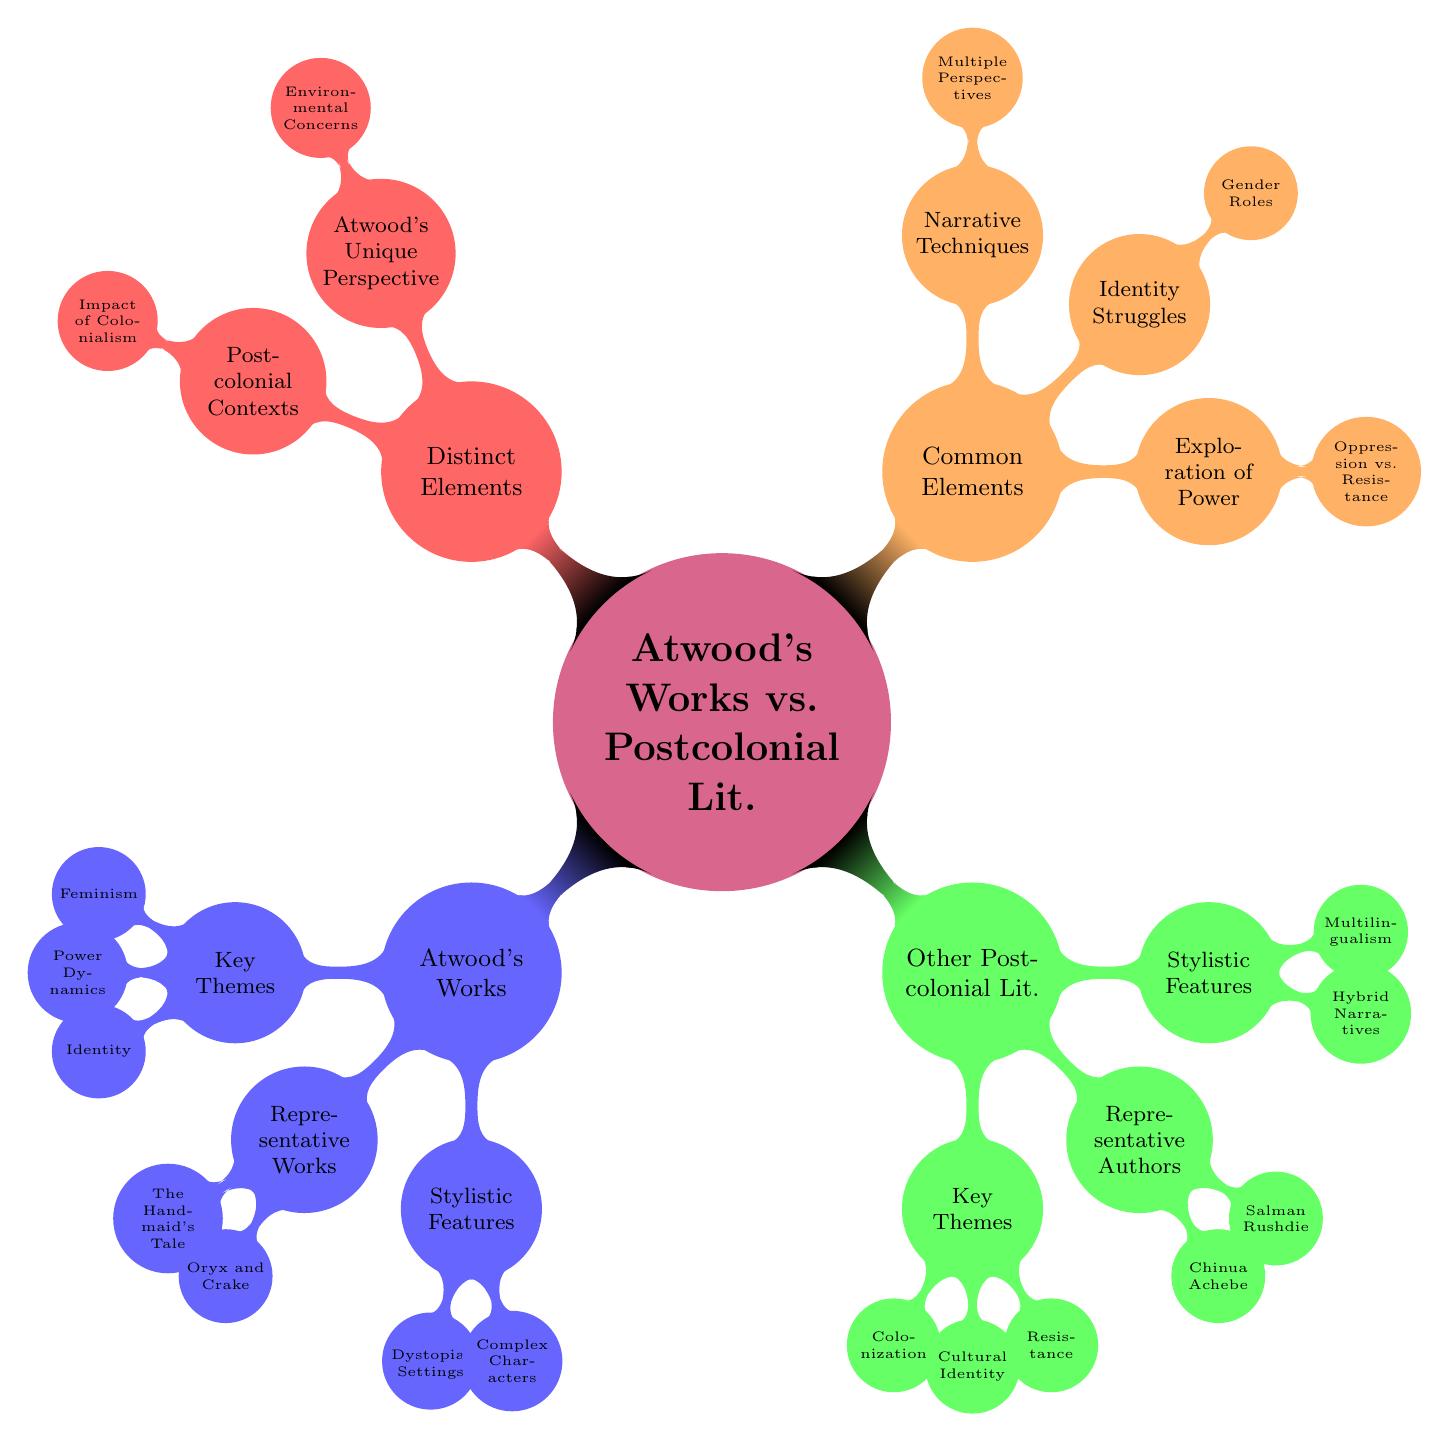What are the key themes in Atwood's works? By looking under the "Atwood's Works" node, the "Key Themes" sub-node lists three items: Feminism, Power Dynamics, and Identity.
Answer: Feminism, Power Dynamics, Identity Who is a representative author of other postcolonial literature? Under the "Other Postcolonial Literature" node, the "Representative Authors" sub-node includes Chinua Achebe, Salman Rushdie, and Arundhati Roy. The first listed is Chinua Achebe.
Answer: Chinua Achebe What are Atwood's unique perspectives compared to other postcolonial contexts? At the "Distinct Elements" node, there are two sub-nodes: "Atwood's Unique Perspective," which includes Environmental Concerns; and "Postcolonial Contexts," which includes the Impact of Colonialism. These represent the unique aspects of Atwood's work.
Answer: Environmental Concerns How many representative works are mentioned for Atwood? Under "Atwood's Works," the "Representative Works" sub-node lists three works: The Handmaid's Tale, Oryx and Crake, and The Blind Assassin. Counting these gives a total of three representative works.
Answer: 3 What narrative techniques are common elements in both Atwood's works and other postcolonial literature? The "Common Elements" node includes a sub-node for "Narrative Techniques," which lists Multiple Perspectives and Symbolism. This indicates a shared aspect in their narrative styles.
Answer: Multiple Perspectives, Symbolism What key theme in other postcolonial literature relates to resistance? The "Key Themes" under "Other Postcolonial Literature" includes Resistance along with Colonization and Cultural Identity. The query is seeking the direct mention of Resistance, which is explicitly listed.
Answer: Resistance What type of settings are common in Atwood's works? The "Stylistic Features" node under "Atwood's Works" contains the sub-node "Dystopian Settings," which indicates that this is a defining feature of Atwood's literary style.
Answer: Dystopian Settings How does Atwood's works differ from postcolonial contexts in narrative focus? Comparing the "Distinct Elements" node shows "Atwood's Unique Perspective" centers on future societies while "Postcolonial Contexts" focuses on the impact of colonialism, suggesting Atwood emphasizes futuristic themes.
Answer: Future Societies, Impact of Colonialism 